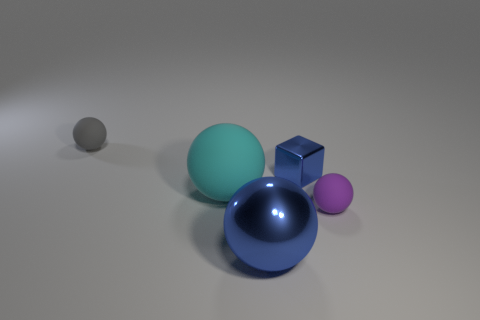Add 2 large balls. How many objects exist? 7 Subtract all blocks. How many objects are left? 4 Subtract 0 green spheres. How many objects are left? 5 Subtract all small spheres. Subtract all big metallic balls. How many objects are left? 2 Add 4 small cubes. How many small cubes are left? 5 Add 1 gray objects. How many gray objects exist? 2 